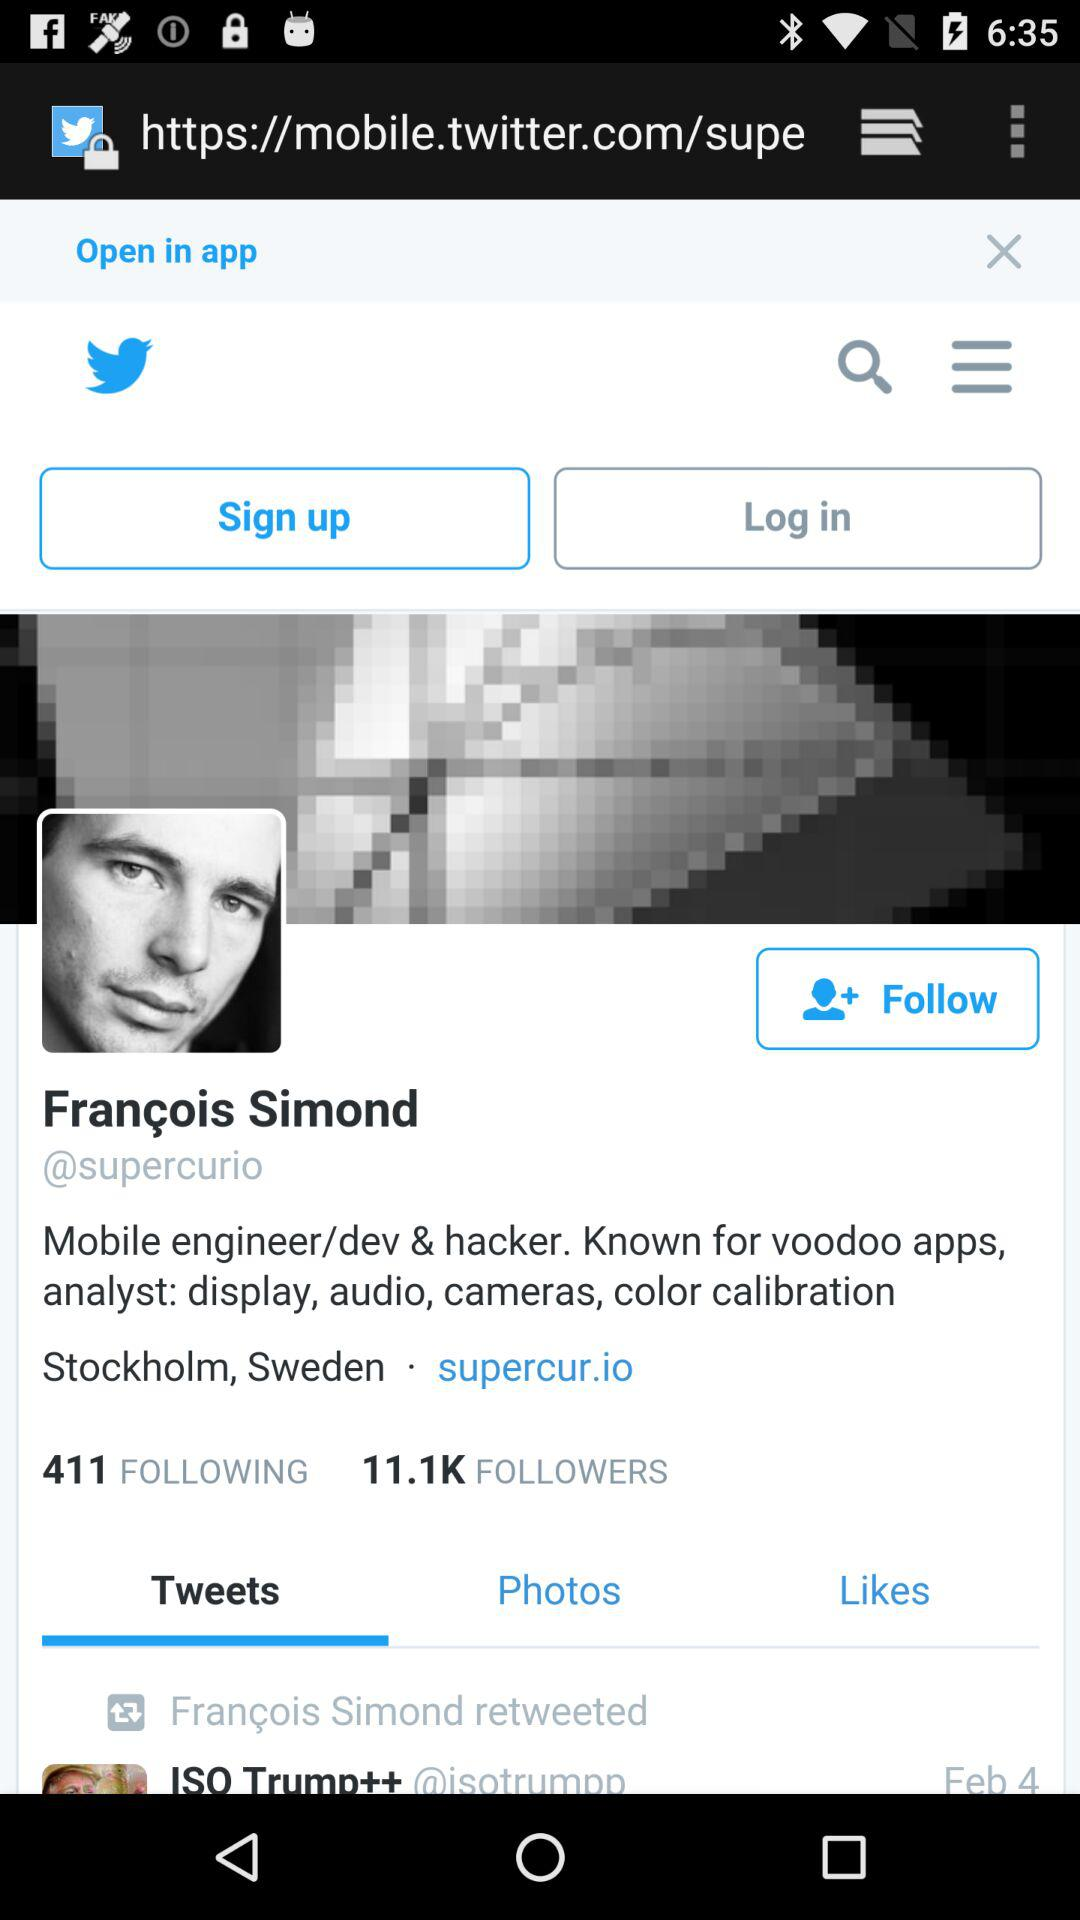Which tab is selected? The selected tab is "Tweets". 